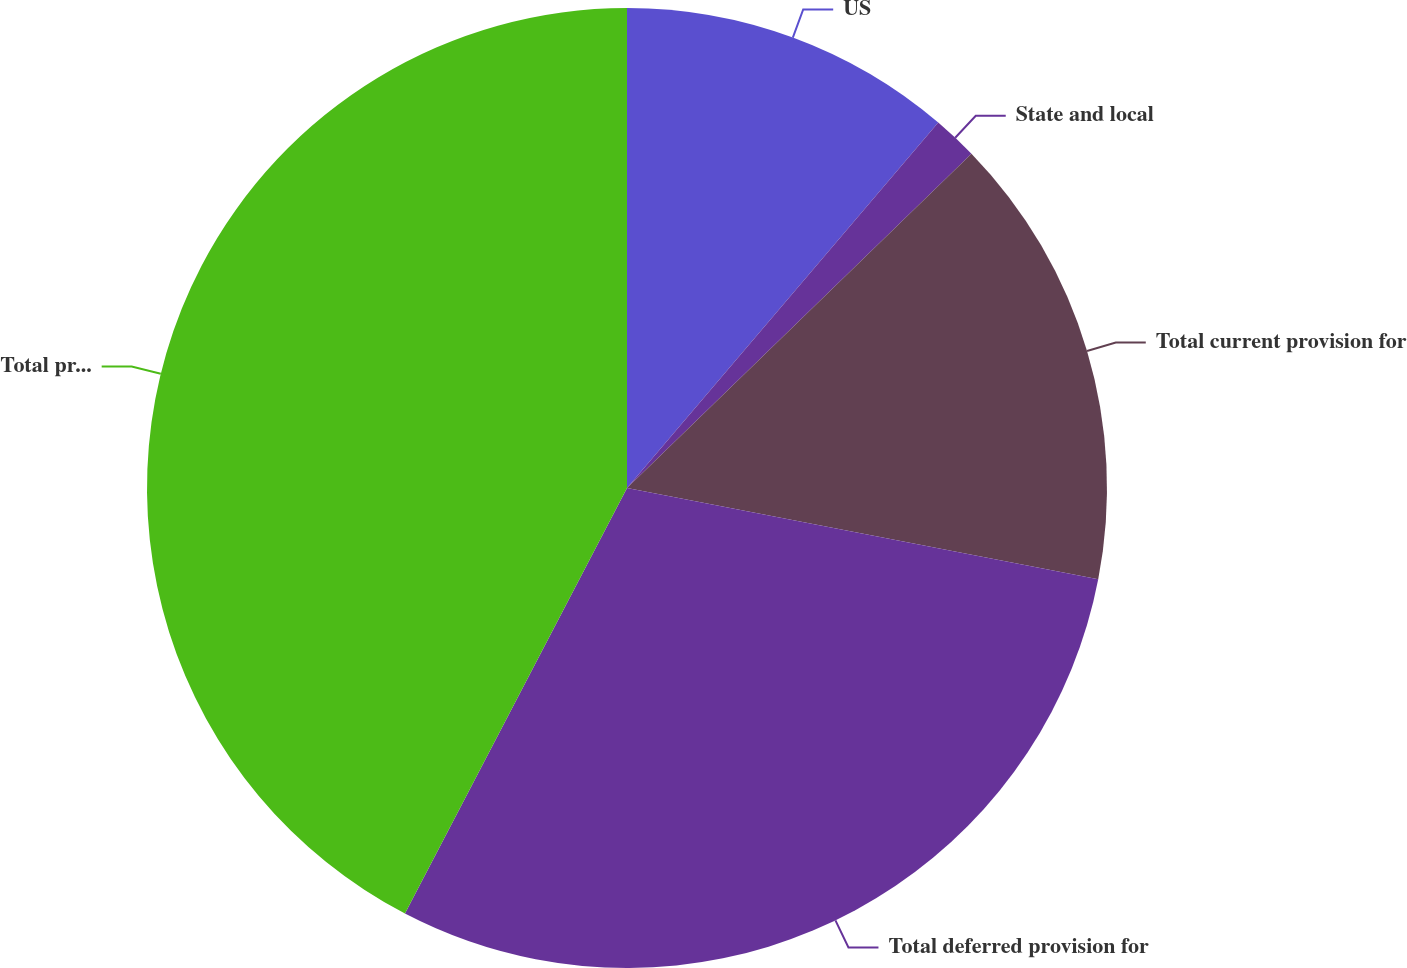Convert chart to OTSL. <chart><loc_0><loc_0><loc_500><loc_500><pie_chart><fcel>US<fcel>State and local<fcel>Total current provision for<fcel>Total deferred provision for<fcel>Total provision for taxes<nl><fcel>11.23%<fcel>1.51%<fcel>15.31%<fcel>29.61%<fcel>42.35%<nl></chart> 